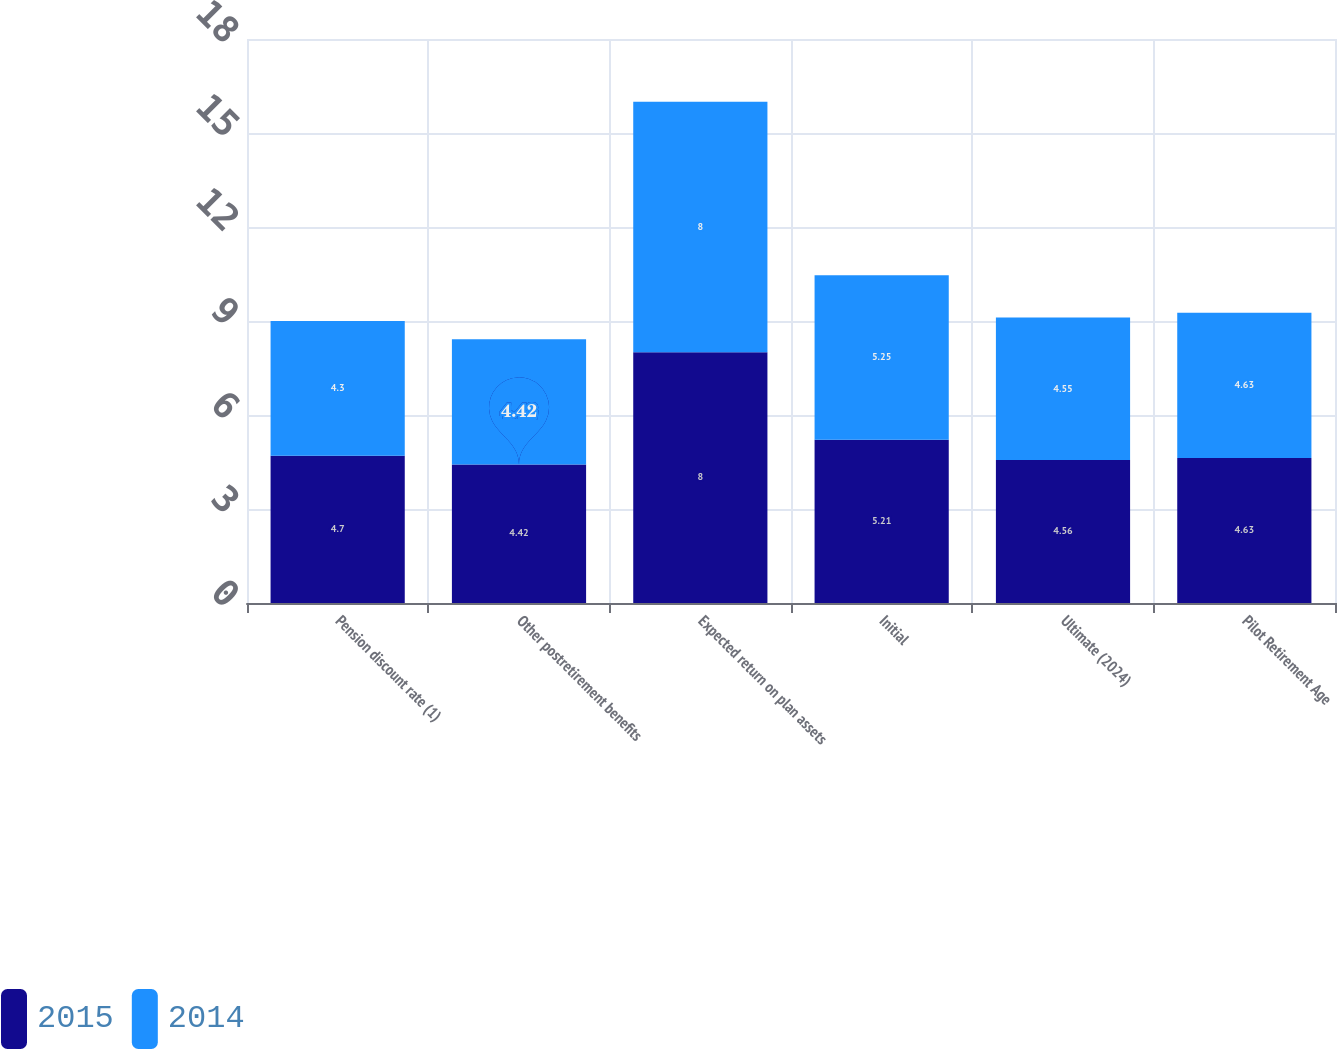Convert chart to OTSL. <chart><loc_0><loc_0><loc_500><loc_500><stacked_bar_chart><ecel><fcel>Pension discount rate (1)<fcel>Other postretirement benefits<fcel>Expected return on plan assets<fcel>Initial<fcel>Ultimate (2024)<fcel>Pilot Retirement Age<nl><fcel>2015<fcel>4.7<fcel>4.42<fcel>8<fcel>5.21<fcel>4.56<fcel>4.63<nl><fcel>2014<fcel>4.3<fcel>4<fcel>8<fcel>5.25<fcel>4.55<fcel>4.63<nl></chart> 